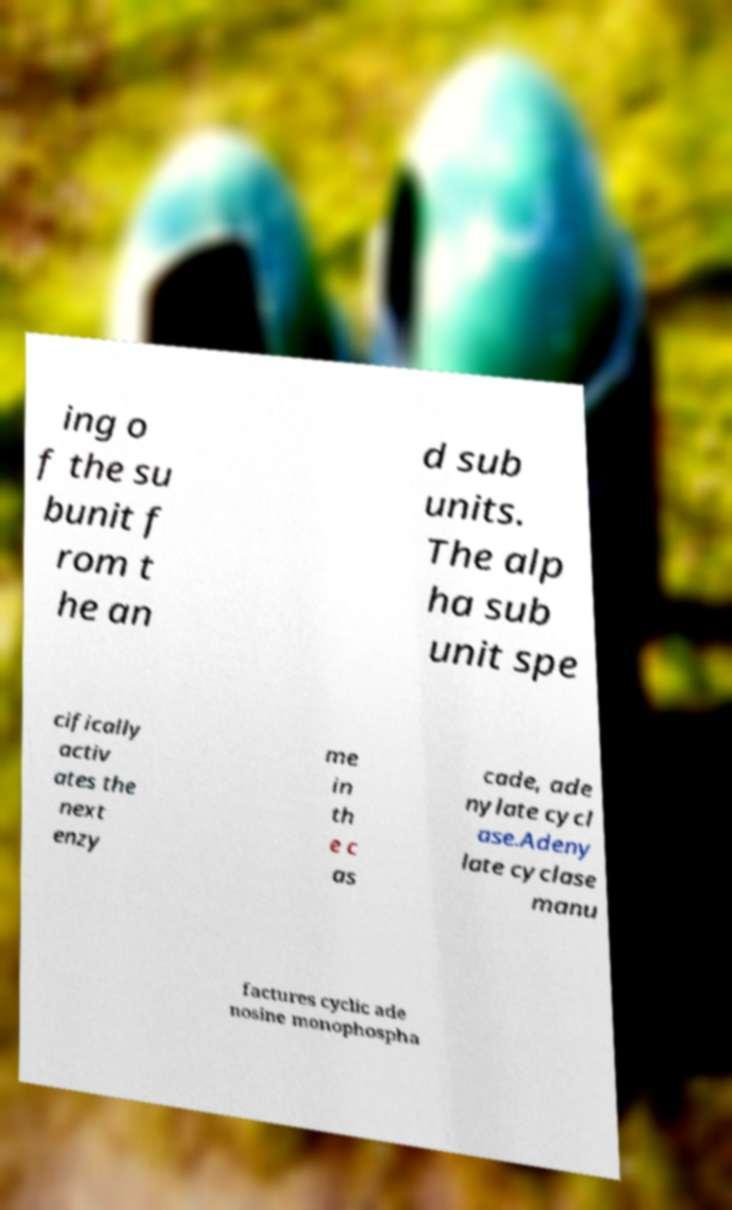Can you read and provide the text displayed in the image?This photo seems to have some interesting text. Can you extract and type it out for me? ing o f the su bunit f rom t he an d sub units. The alp ha sub unit spe cifically activ ates the next enzy me in th e c as cade, ade nylate cycl ase.Adeny late cyclase manu factures cyclic ade nosine monophospha 